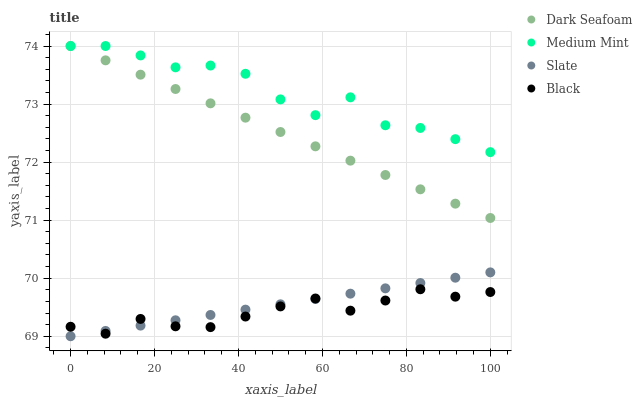Does Black have the minimum area under the curve?
Answer yes or no. Yes. Does Medium Mint have the maximum area under the curve?
Answer yes or no. Yes. Does Dark Seafoam have the minimum area under the curve?
Answer yes or no. No. Does Dark Seafoam have the maximum area under the curve?
Answer yes or no. No. Is Dark Seafoam the smoothest?
Answer yes or no. Yes. Is Medium Mint the roughest?
Answer yes or no. Yes. Is Black the smoothest?
Answer yes or no. No. Is Black the roughest?
Answer yes or no. No. Does Slate have the lowest value?
Answer yes or no. Yes. Does Dark Seafoam have the lowest value?
Answer yes or no. No. Does Dark Seafoam have the highest value?
Answer yes or no. Yes. Does Black have the highest value?
Answer yes or no. No. Is Slate less than Medium Mint?
Answer yes or no. Yes. Is Medium Mint greater than Slate?
Answer yes or no. Yes. Does Medium Mint intersect Dark Seafoam?
Answer yes or no. Yes. Is Medium Mint less than Dark Seafoam?
Answer yes or no. No. Is Medium Mint greater than Dark Seafoam?
Answer yes or no. No. Does Slate intersect Medium Mint?
Answer yes or no. No. 